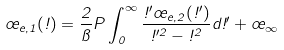<formula> <loc_0><loc_0><loc_500><loc_500>\sigma _ { e , 1 } ( \omega ) = \frac { 2 } { \pi } P \int _ { 0 } ^ { \infty } \frac { \omega ^ { \prime } \sigma _ { e , 2 } ( \omega ^ { \prime } ) } { \omega ^ { \prime 2 } - \omega ^ { 2 } } d \omega ^ { \prime } + \sigma _ { \infty }</formula> 